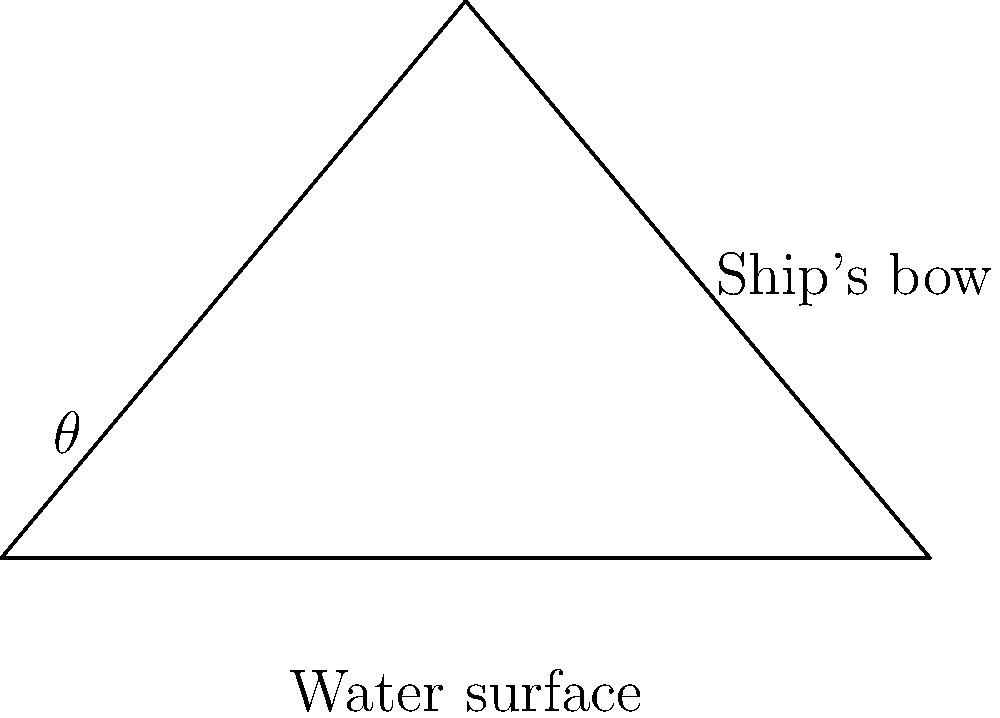As a naval architect, you're tasked with designing a ship's bow to minimize water resistance. Given that the optimal angle $\theta$ for the bow is determined by the formula $\theta = \arctan(\frac{1}{\sqrt{3}})$, calculate the optimal angle in degrees to the nearest whole number. To solve this problem, we'll follow these steps:

1) The formula given is $\theta = \arctan(\frac{1}{\sqrt{3}})$

2) First, let's calculate $\frac{1}{\sqrt{3}}$:
   $\frac{1}{\sqrt{3}} \approx 0.5774$

3) Now, we can calculate $\theta$:
   $\theta = \arctan(0.5774)$

4) Using a calculator or computer, we get:
   $\theta \approx 0.5236$ radians

5) To convert radians to degrees, we multiply by $\frac{180}{\pi}$:
   $\theta \approx 0.5236 \times \frac{180}{\pi} \approx 30.0°$

6) Rounding to the nearest whole number:
   $\theta \approx 30°$

This angle of 30° provides the optimal balance between cutting through the water and deflecting it, minimizing resistance for the ship's bow.
Answer: 30° 